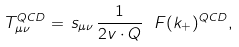Convert formula to latex. <formula><loc_0><loc_0><loc_500><loc_500>T _ { \mu \nu } ^ { Q C D } = \, s _ { \mu \nu } \, \frac { 1 } { 2 v \cdot Q } \ F ( k _ { + } ) ^ { Q C D } ,</formula> 